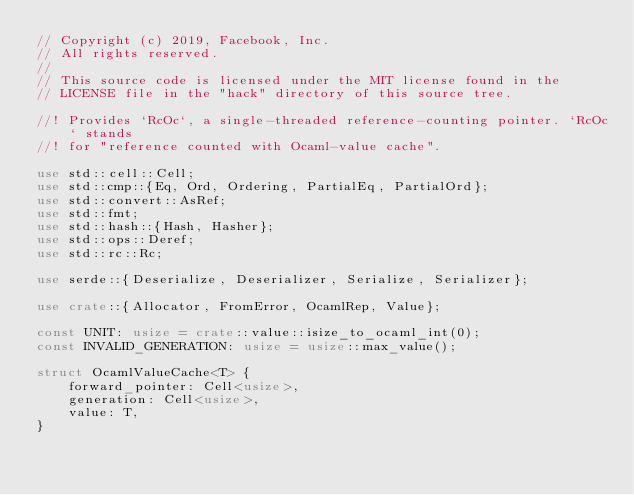Convert code to text. <code><loc_0><loc_0><loc_500><loc_500><_Rust_>// Copyright (c) 2019, Facebook, Inc.
// All rights reserved.
//
// This source code is licensed under the MIT license found in the
// LICENSE file in the "hack" directory of this source tree.

//! Provides `RcOc`, a single-threaded reference-counting pointer. `RcOc` stands
//! for "reference counted with Ocaml-value cache".

use std::cell::Cell;
use std::cmp::{Eq, Ord, Ordering, PartialEq, PartialOrd};
use std::convert::AsRef;
use std::fmt;
use std::hash::{Hash, Hasher};
use std::ops::Deref;
use std::rc::Rc;

use serde::{Deserialize, Deserializer, Serialize, Serializer};

use crate::{Allocator, FromError, OcamlRep, Value};

const UNIT: usize = crate::value::isize_to_ocaml_int(0);
const INVALID_GENERATION: usize = usize::max_value();

struct OcamlValueCache<T> {
    forward_pointer: Cell<usize>,
    generation: Cell<usize>,
    value: T,
}
</code> 